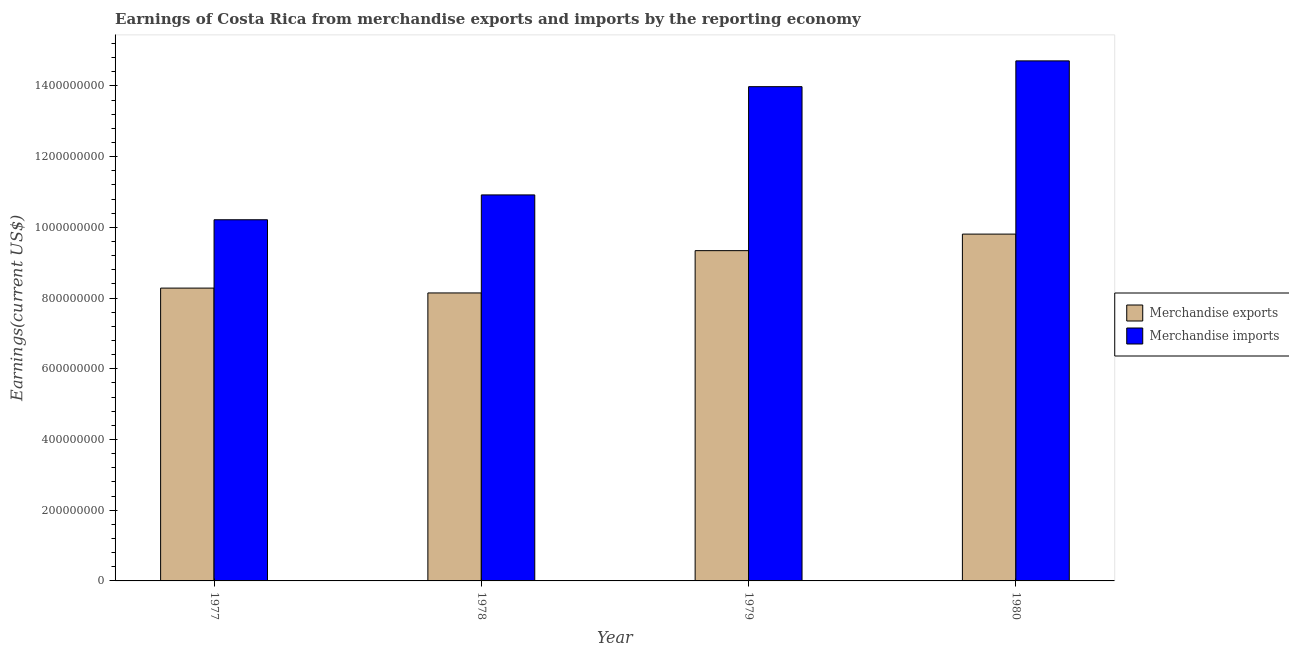How many different coloured bars are there?
Your answer should be very brief. 2. How many groups of bars are there?
Provide a short and direct response. 4. How many bars are there on the 1st tick from the left?
Offer a very short reply. 2. How many bars are there on the 4th tick from the right?
Offer a very short reply. 2. What is the label of the 3rd group of bars from the left?
Give a very brief answer. 1979. What is the earnings from merchandise imports in 1977?
Offer a terse response. 1.02e+09. Across all years, what is the maximum earnings from merchandise imports?
Make the answer very short. 1.47e+09. Across all years, what is the minimum earnings from merchandise exports?
Your answer should be compact. 8.14e+08. What is the total earnings from merchandise exports in the graph?
Keep it short and to the point. 3.56e+09. What is the difference between the earnings from merchandise imports in 1977 and that in 1979?
Provide a succinct answer. -3.76e+08. What is the difference between the earnings from merchandise imports in 1977 and the earnings from merchandise exports in 1978?
Keep it short and to the point. -7.03e+07. What is the average earnings from merchandise imports per year?
Your response must be concise. 1.25e+09. In how many years, is the earnings from merchandise imports greater than 800000000 US$?
Your response must be concise. 4. What is the ratio of the earnings from merchandise exports in 1978 to that in 1979?
Give a very brief answer. 0.87. What is the difference between the highest and the second highest earnings from merchandise exports?
Your answer should be compact. 4.68e+07. What is the difference between the highest and the lowest earnings from merchandise imports?
Keep it short and to the point. 4.49e+08. What does the 1st bar from the right in 1979 represents?
Keep it short and to the point. Merchandise imports. Are all the bars in the graph horizontal?
Provide a short and direct response. No. How many years are there in the graph?
Keep it short and to the point. 4. Are the values on the major ticks of Y-axis written in scientific E-notation?
Offer a terse response. No. Does the graph contain grids?
Your answer should be compact. No. Where does the legend appear in the graph?
Keep it short and to the point. Center right. What is the title of the graph?
Offer a very short reply. Earnings of Costa Rica from merchandise exports and imports by the reporting economy. Does "Nitrous oxide emissions" appear as one of the legend labels in the graph?
Offer a terse response. No. What is the label or title of the X-axis?
Keep it short and to the point. Year. What is the label or title of the Y-axis?
Provide a succinct answer. Earnings(current US$). What is the Earnings(current US$) in Merchandise exports in 1977?
Give a very brief answer. 8.28e+08. What is the Earnings(current US$) of Merchandise imports in 1977?
Provide a succinct answer. 1.02e+09. What is the Earnings(current US$) of Merchandise exports in 1978?
Your response must be concise. 8.14e+08. What is the Earnings(current US$) of Merchandise imports in 1978?
Give a very brief answer. 1.09e+09. What is the Earnings(current US$) of Merchandise exports in 1979?
Offer a terse response. 9.34e+08. What is the Earnings(current US$) of Merchandise imports in 1979?
Offer a terse response. 1.40e+09. What is the Earnings(current US$) of Merchandise exports in 1980?
Ensure brevity in your answer.  9.81e+08. What is the Earnings(current US$) in Merchandise imports in 1980?
Provide a short and direct response. 1.47e+09. Across all years, what is the maximum Earnings(current US$) of Merchandise exports?
Offer a very short reply. 9.81e+08. Across all years, what is the maximum Earnings(current US$) in Merchandise imports?
Provide a succinct answer. 1.47e+09. Across all years, what is the minimum Earnings(current US$) of Merchandise exports?
Your answer should be compact. 8.14e+08. Across all years, what is the minimum Earnings(current US$) of Merchandise imports?
Give a very brief answer. 1.02e+09. What is the total Earnings(current US$) in Merchandise exports in the graph?
Provide a succinct answer. 3.56e+09. What is the total Earnings(current US$) in Merchandise imports in the graph?
Give a very brief answer. 4.98e+09. What is the difference between the Earnings(current US$) in Merchandise exports in 1977 and that in 1978?
Offer a terse response. 1.37e+07. What is the difference between the Earnings(current US$) of Merchandise imports in 1977 and that in 1978?
Keep it short and to the point. -7.03e+07. What is the difference between the Earnings(current US$) of Merchandise exports in 1977 and that in 1979?
Give a very brief answer. -1.06e+08. What is the difference between the Earnings(current US$) of Merchandise imports in 1977 and that in 1979?
Offer a very short reply. -3.76e+08. What is the difference between the Earnings(current US$) in Merchandise exports in 1977 and that in 1980?
Your answer should be compact. -1.53e+08. What is the difference between the Earnings(current US$) in Merchandise imports in 1977 and that in 1980?
Give a very brief answer. -4.49e+08. What is the difference between the Earnings(current US$) in Merchandise exports in 1978 and that in 1979?
Ensure brevity in your answer.  -1.20e+08. What is the difference between the Earnings(current US$) in Merchandise imports in 1978 and that in 1979?
Offer a very short reply. -3.06e+08. What is the difference between the Earnings(current US$) in Merchandise exports in 1978 and that in 1980?
Offer a very short reply. -1.66e+08. What is the difference between the Earnings(current US$) of Merchandise imports in 1978 and that in 1980?
Your answer should be compact. -3.79e+08. What is the difference between the Earnings(current US$) in Merchandise exports in 1979 and that in 1980?
Keep it short and to the point. -4.68e+07. What is the difference between the Earnings(current US$) of Merchandise imports in 1979 and that in 1980?
Give a very brief answer. -7.29e+07. What is the difference between the Earnings(current US$) of Merchandise exports in 1977 and the Earnings(current US$) of Merchandise imports in 1978?
Your answer should be very brief. -2.64e+08. What is the difference between the Earnings(current US$) of Merchandise exports in 1977 and the Earnings(current US$) of Merchandise imports in 1979?
Provide a succinct answer. -5.70e+08. What is the difference between the Earnings(current US$) of Merchandise exports in 1977 and the Earnings(current US$) of Merchandise imports in 1980?
Offer a very short reply. -6.43e+08. What is the difference between the Earnings(current US$) in Merchandise exports in 1978 and the Earnings(current US$) in Merchandise imports in 1979?
Provide a short and direct response. -5.83e+08. What is the difference between the Earnings(current US$) in Merchandise exports in 1978 and the Earnings(current US$) in Merchandise imports in 1980?
Provide a short and direct response. -6.56e+08. What is the difference between the Earnings(current US$) of Merchandise exports in 1979 and the Earnings(current US$) of Merchandise imports in 1980?
Give a very brief answer. -5.37e+08. What is the average Earnings(current US$) of Merchandise exports per year?
Offer a terse response. 8.89e+08. What is the average Earnings(current US$) of Merchandise imports per year?
Your response must be concise. 1.25e+09. In the year 1977, what is the difference between the Earnings(current US$) of Merchandise exports and Earnings(current US$) of Merchandise imports?
Ensure brevity in your answer.  -1.93e+08. In the year 1978, what is the difference between the Earnings(current US$) in Merchandise exports and Earnings(current US$) in Merchandise imports?
Offer a very short reply. -2.77e+08. In the year 1979, what is the difference between the Earnings(current US$) of Merchandise exports and Earnings(current US$) of Merchandise imports?
Offer a very short reply. -4.64e+08. In the year 1980, what is the difference between the Earnings(current US$) of Merchandise exports and Earnings(current US$) of Merchandise imports?
Your answer should be very brief. -4.90e+08. What is the ratio of the Earnings(current US$) of Merchandise exports in 1977 to that in 1978?
Keep it short and to the point. 1.02. What is the ratio of the Earnings(current US$) of Merchandise imports in 1977 to that in 1978?
Give a very brief answer. 0.94. What is the ratio of the Earnings(current US$) in Merchandise exports in 1977 to that in 1979?
Give a very brief answer. 0.89. What is the ratio of the Earnings(current US$) of Merchandise imports in 1977 to that in 1979?
Offer a terse response. 0.73. What is the ratio of the Earnings(current US$) in Merchandise exports in 1977 to that in 1980?
Your response must be concise. 0.84. What is the ratio of the Earnings(current US$) of Merchandise imports in 1977 to that in 1980?
Make the answer very short. 0.69. What is the ratio of the Earnings(current US$) in Merchandise exports in 1978 to that in 1979?
Ensure brevity in your answer.  0.87. What is the ratio of the Earnings(current US$) in Merchandise imports in 1978 to that in 1979?
Provide a short and direct response. 0.78. What is the ratio of the Earnings(current US$) in Merchandise exports in 1978 to that in 1980?
Make the answer very short. 0.83. What is the ratio of the Earnings(current US$) of Merchandise imports in 1978 to that in 1980?
Your response must be concise. 0.74. What is the ratio of the Earnings(current US$) in Merchandise exports in 1979 to that in 1980?
Provide a short and direct response. 0.95. What is the ratio of the Earnings(current US$) of Merchandise imports in 1979 to that in 1980?
Offer a very short reply. 0.95. What is the difference between the highest and the second highest Earnings(current US$) of Merchandise exports?
Offer a very short reply. 4.68e+07. What is the difference between the highest and the second highest Earnings(current US$) of Merchandise imports?
Keep it short and to the point. 7.29e+07. What is the difference between the highest and the lowest Earnings(current US$) of Merchandise exports?
Ensure brevity in your answer.  1.66e+08. What is the difference between the highest and the lowest Earnings(current US$) of Merchandise imports?
Offer a very short reply. 4.49e+08. 